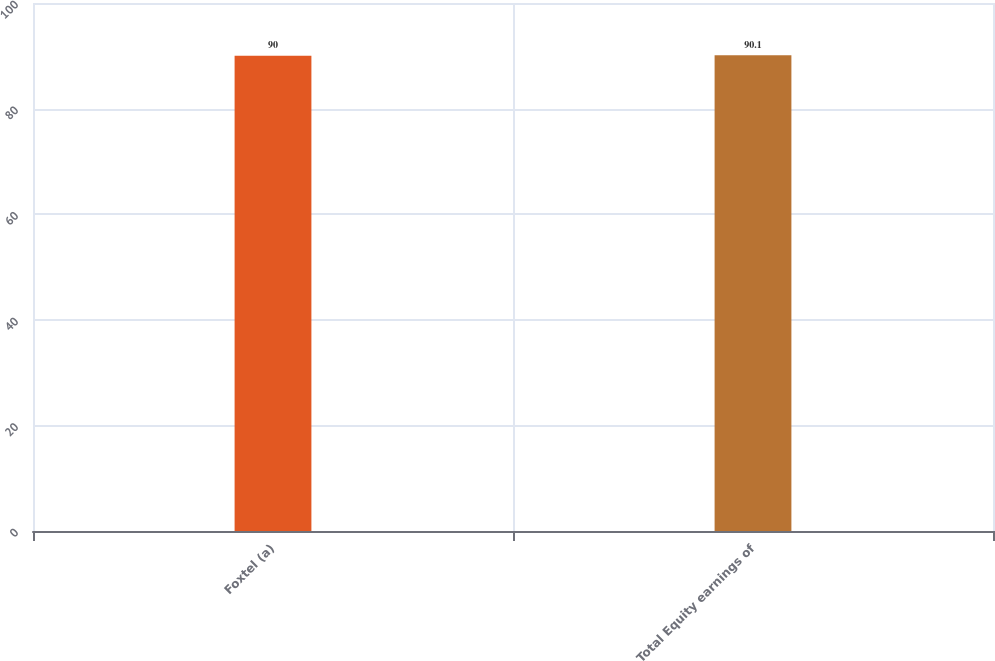Convert chart to OTSL. <chart><loc_0><loc_0><loc_500><loc_500><bar_chart><fcel>Foxtel (a)<fcel>Total Equity earnings of<nl><fcel>90<fcel>90.1<nl></chart> 